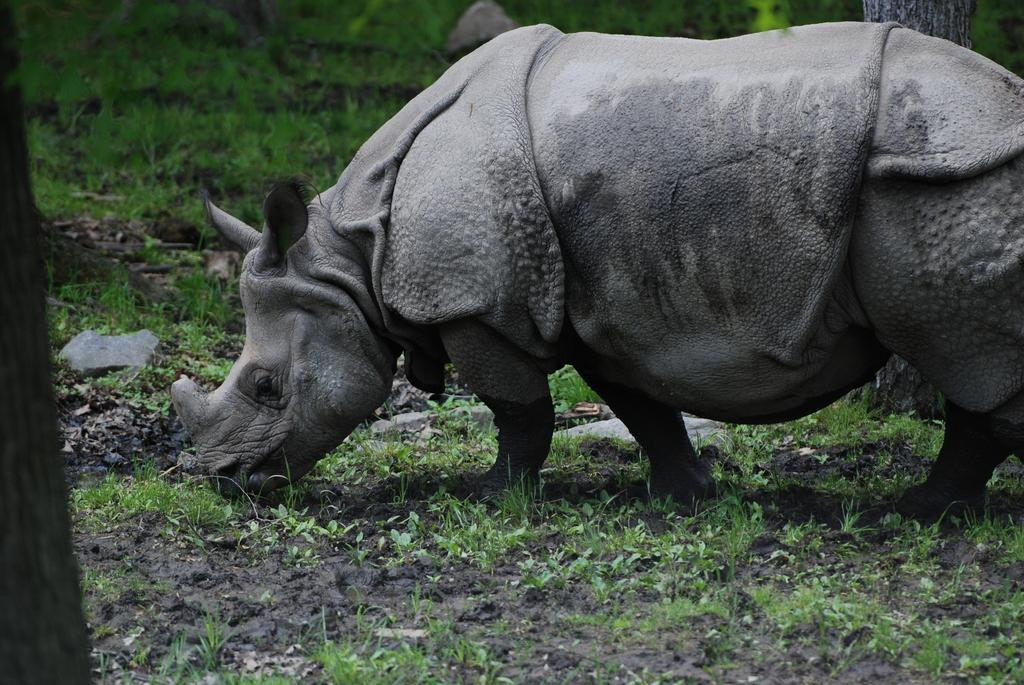What animal can be seen in the picture? There is a rhinoceros in the picture. What is the rhinoceros doing in the image? The rhinoceros is grazing. What type of vegetation is present in the foreground of the image? There are plants and grass in the foreground of the image. What type of terrain is visible in the foreground of the image? There is mud in the foreground of the image. Can you describe the background of the image? The background of the image is blurred, but there is grass, a stone, and a tree visible. What type of railway can be seen in the background of the image? There is no railway present in the image; it features a rhinoceros grazing in a natural environment. What type of arch is visible above the rhinoceros in the image? There is no arch present in the image; it features a rhinoceros grazing in a natural environment. 